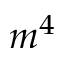<formula> <loc_0><loc_0><loc_500><loc_500>m ^ { 4 }</formula> 